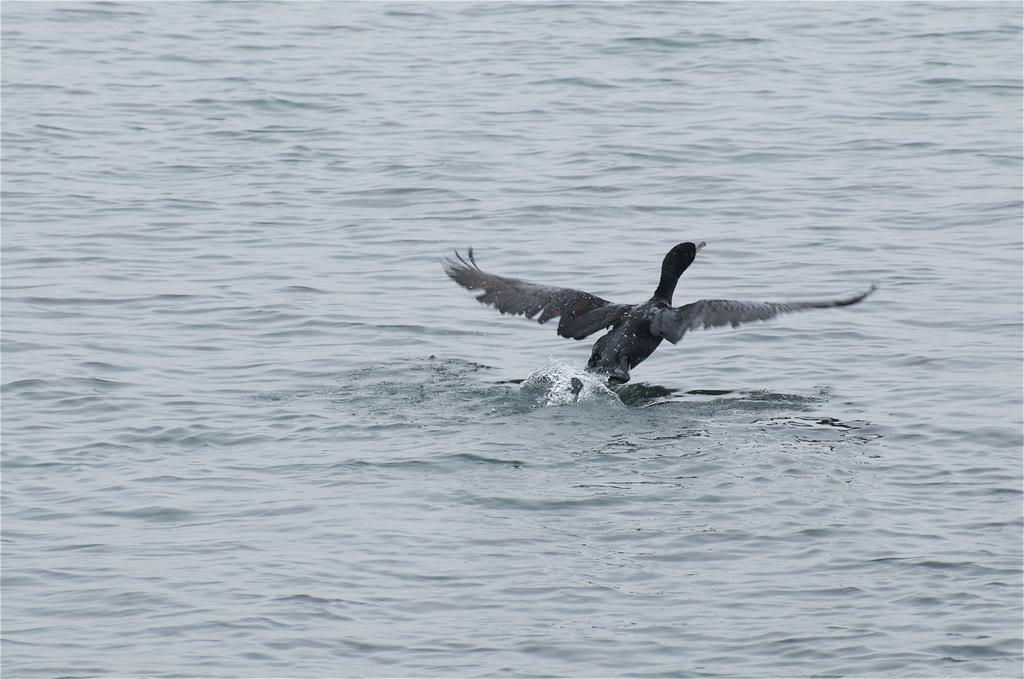What is present in the image that is not solid? There is water visible in the image. What type of animal can be seen in the image? There is a bird in the image. What type of tub is the bird using in the image? There is no tub present in the image; it features water and a bird. Can you tell me who the guide is in the image? There is no guide present in the image; it features water and a bird. 